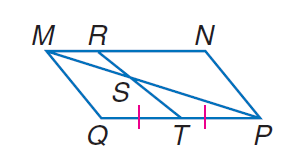Answer the mathemtical geometry problem and directly provide the correct option letter.
Question: Find the ratio of M S to S P, given that M N P Q is a parallelogram with M R = \frac { 1 } { 4 } M N.
Choices: A: 0.25 B: 0.5 C: 1 D: 2 B 